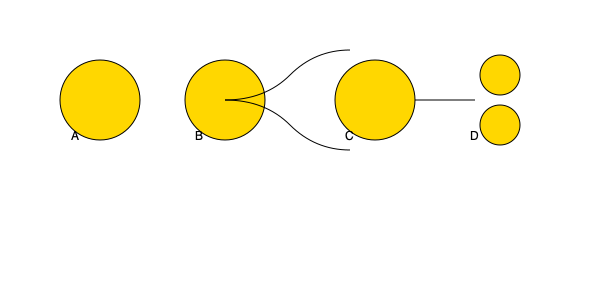As a medical professional examining microscope images of cell division, identify the stage represented by image B in the diagram above. To identify the stage of cell division represented by image B, let's analyze the diagram step-by-step:

1. Image A shows a single circular structure, likely representing a cell in interphase or early prophase.

2. Image B displays a circular structure with two distinct thread-like structures emerging from it. These structures resemble chromosomes being pulled apart.

3. Image C shows a single elongated structure, suggesting the cell is stretching in preparation for division.

4. Image D depicts two separate circular structures, indicating the final stage of cell division.

Based on these observations, image B represents the metaphase stage of mitosis. During metaphase:

- Chromosomes align at the cell's equatorial plane (metaphase plate).
- The nuclear envelope has broken down.
- Spindle fibers attach to the chromosomes' kinetochores.
- The cell prepares for the separation of sister chromatids.

The thread-like structures in image B represent the aligned chromosomes, with spindle fibers pulling them towards opposite poles of the cell, which is characteristic of the metaphase stage.
Answer: Metaphase 